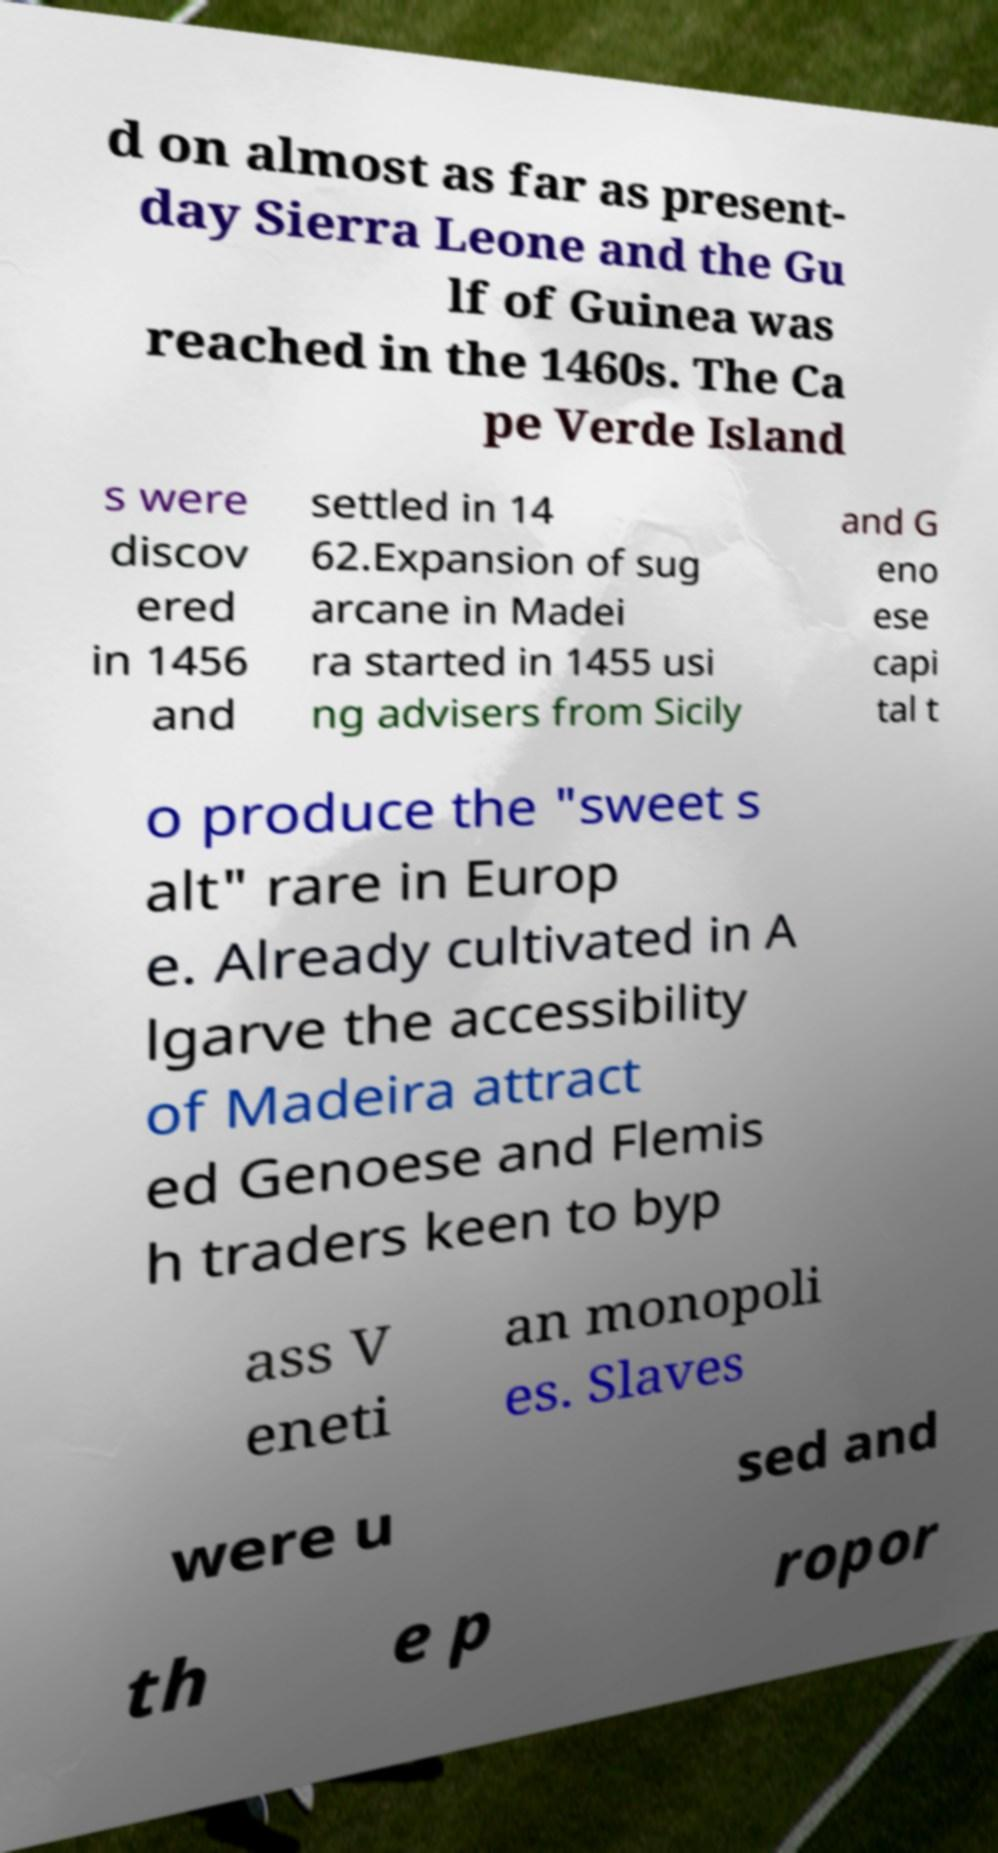Please read and relay the text visible in this image. What does it say? d on almost as far as present- day Sierra Leone and the Gu lf of Guinea was reached in the 1460s. The Ca pe Verde Island s were discov ered in 1456 and settled in 14 62.Expansion of sug arcane in Madei ra started in 1455 usi ng advisers from Sicily and G eno ese capi tal t o produce the "sweet s alt" rare in Europ e. Already cultivated in A lgarve the accessibility of Madeira attract ed Genoese and Flemis h traders keen to byp ass V eneti an monopoli es. Slaves were u sed and th e p ropor 